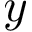<formula> <loc_0><loc_0><loc_500><loc_500>y</formula> 